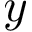<formula> <loc_0><loc_0><loc_500><loc_500>y</formula> 